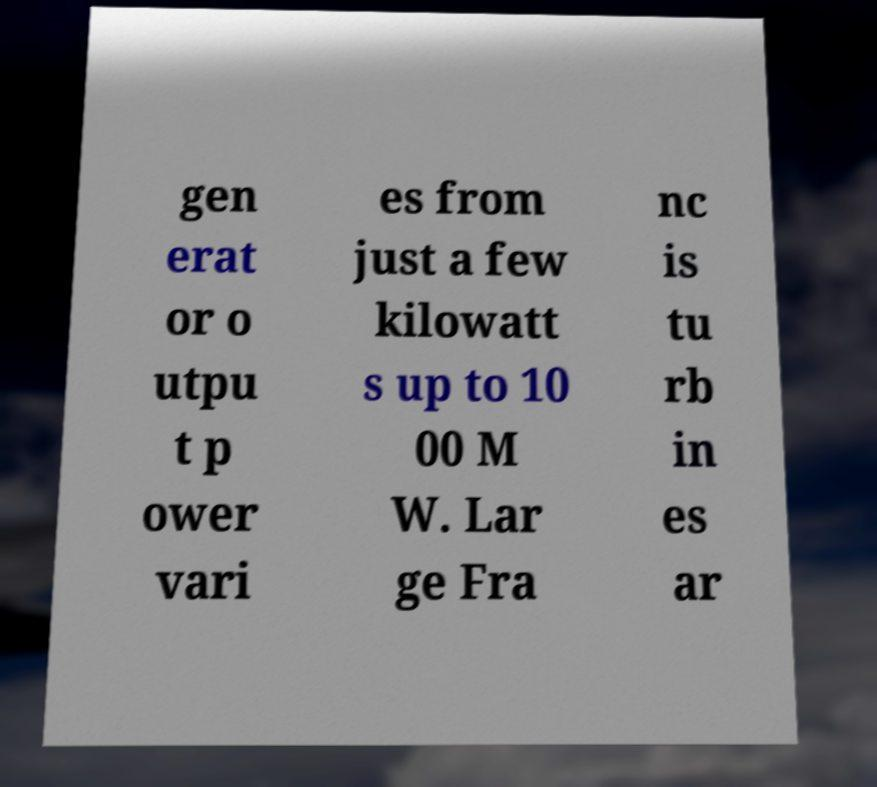What messages or text are displayed in this image? I need them in a readable, typed format. gen erat or o utpu t p ower vari es from just a few kilowatt s up to 10 00 M W. Lar ge Fra nc is tu rb in es ar 